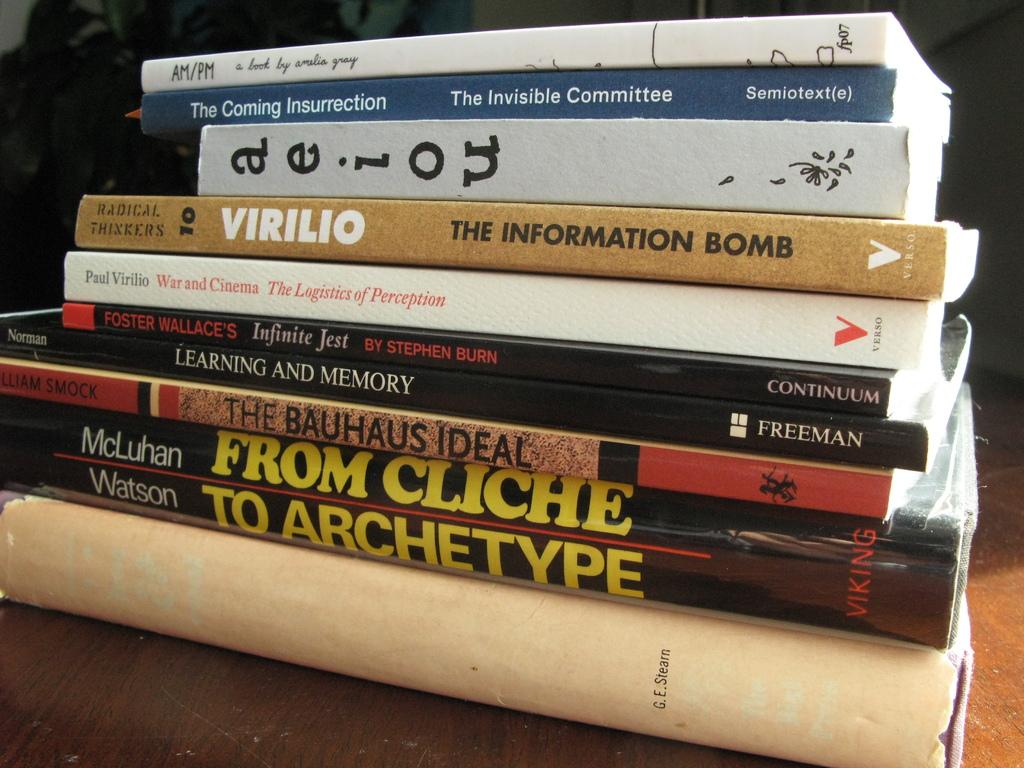What is the second book's title?
Your answer should be compact. From cliche to archetype. Who wrote the second book?
Your answer should be very brief. The invisible committee. 